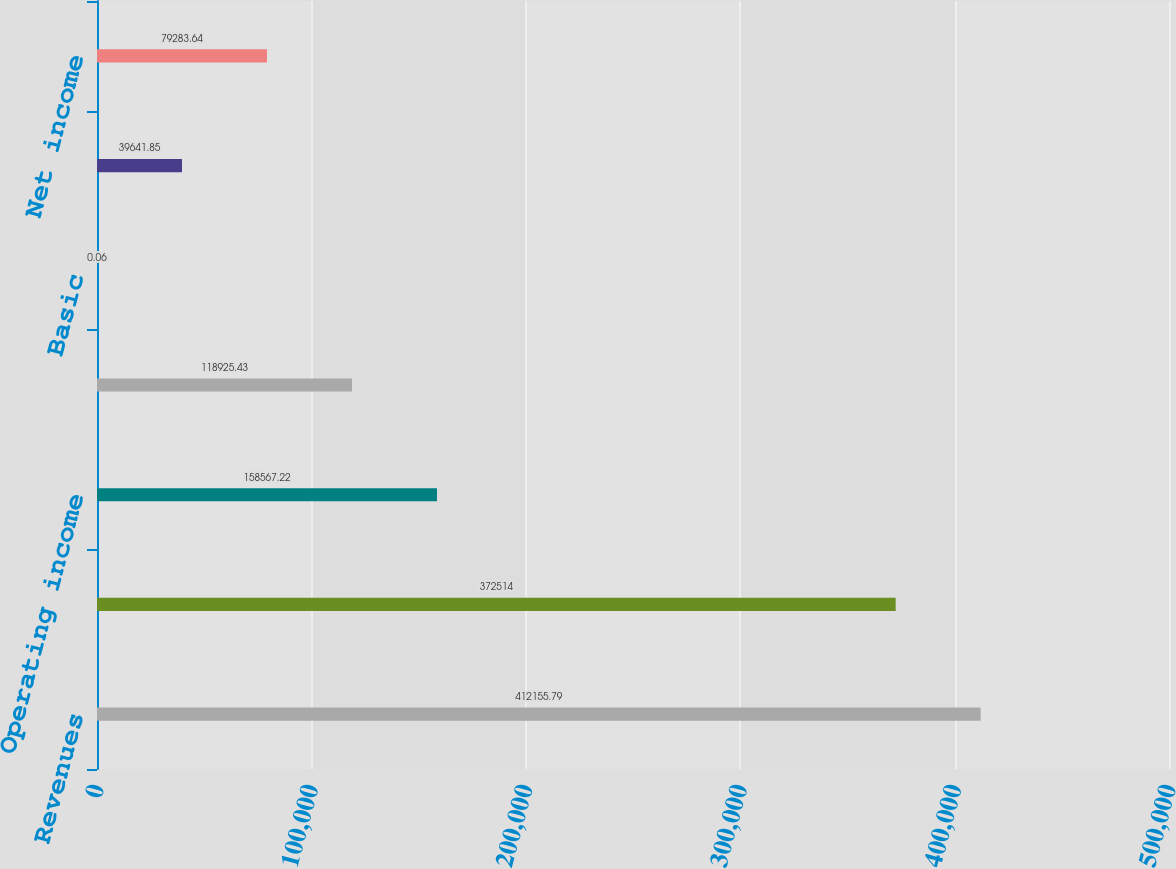Convert chart. <chart><loc_0><loc_0><loc_500><loc_500><bar_chart><fcel>Revenues<fcel>Costs and expenses<fcel>Operating income<fcel>Net income (loss)<fcel>Basic<fcel>Diluted<fcel>Net income<nl><fcel>412156<fcel>372514<fcel>158567<fcel>118925<fcel>0.06<fcel>39641.8<fcel>79283.6<nl></chart> 